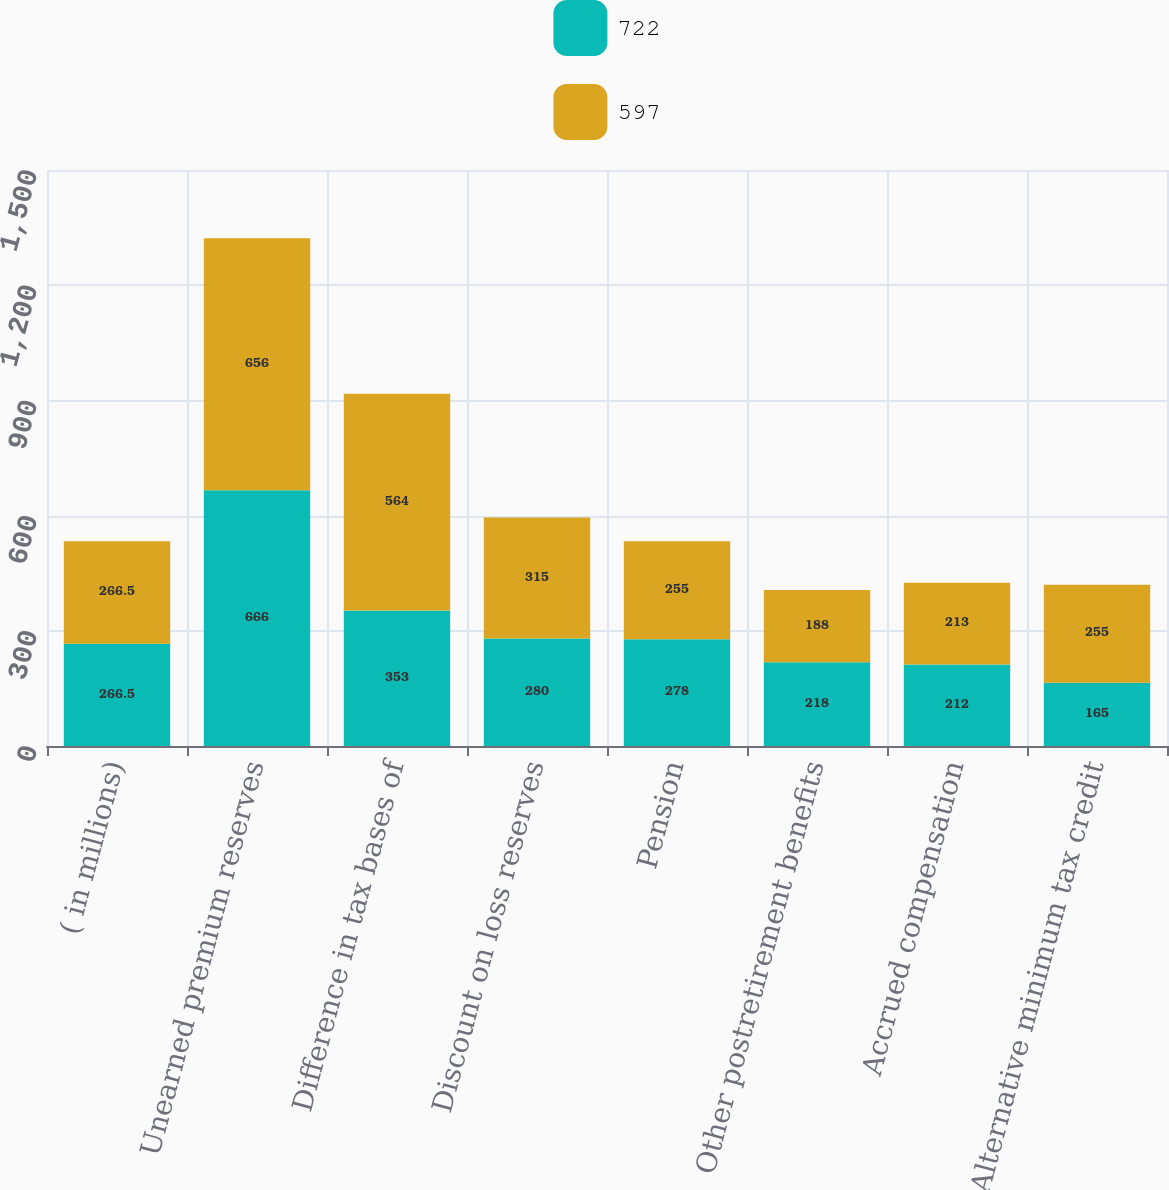Convert chart to OTSL. <chart><loc_0><loc_0><loc_500><loc_500><stacked_bar_chart><ecel><fcel>( in millions)<fcel>Unearned premium reserves<fcel>Difference in tax bases of<fcel>Discount on loss reserves<fcel>Pension<fcel>Other postretirement benefits<fcel>Accrued compensation<fcel>Alternative minimum tax credit<nl><fcel>722<fcel>266.5<fcel>666<fcel>353<fcel>280<fcel>278<fcel>218<fcel>212<fcel>165<nl><fcel>597<fcel>266.5<fcel>656<fcel>564<fcel>315<fcel>255<fcel>188<fcel>213<fcel>255<nl></chart> 